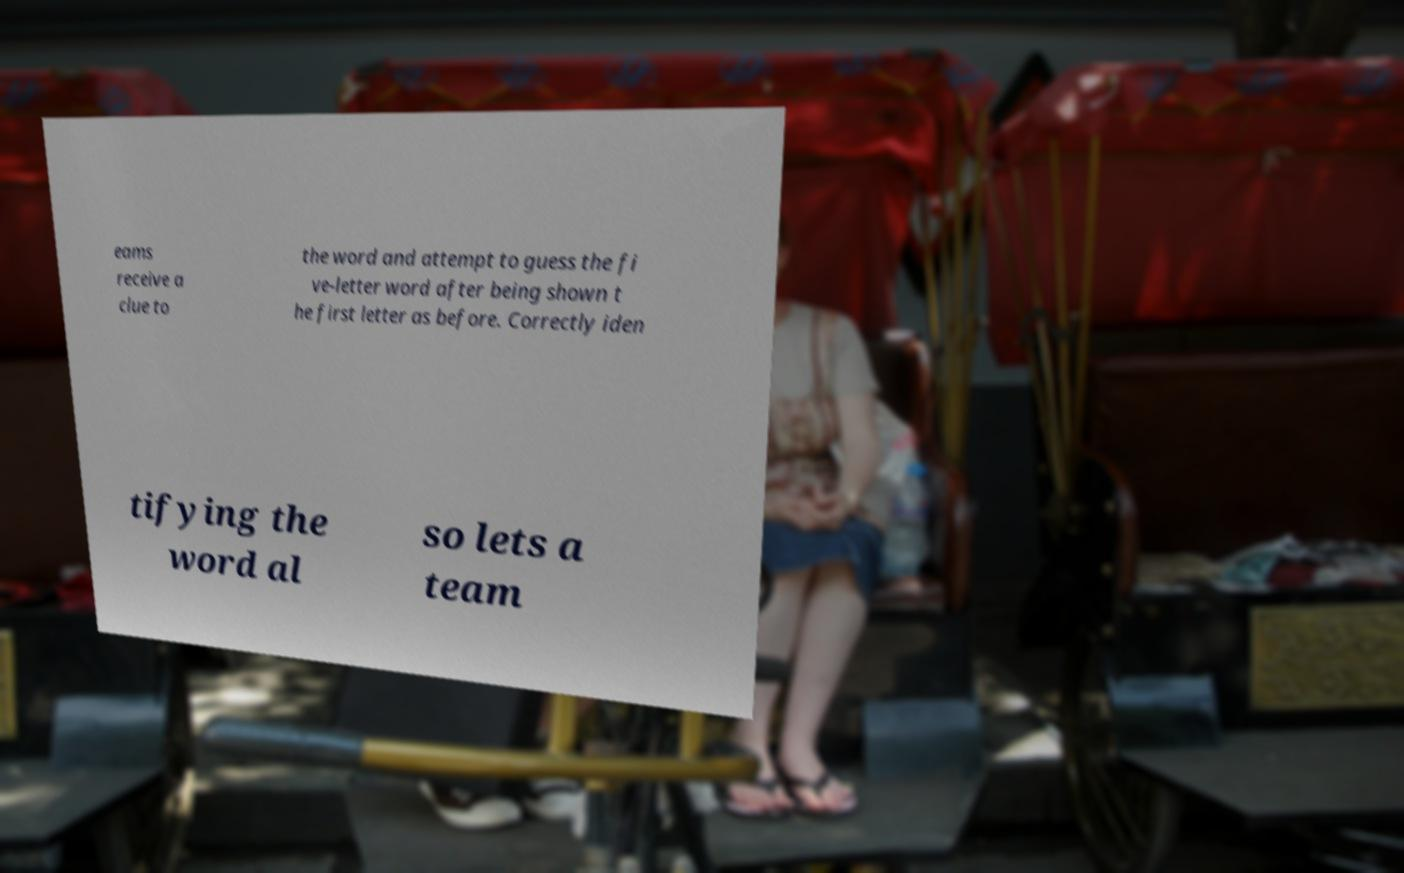Can you read and provide the text displayed in the image?This photo seems to have some interesting text. Can you extract and type it out for me? eams receive a clue to the word and attempt to guess the fi ve-letter word after being shown t he first letter as before. Correctly iden tifying the word al so lets a team 